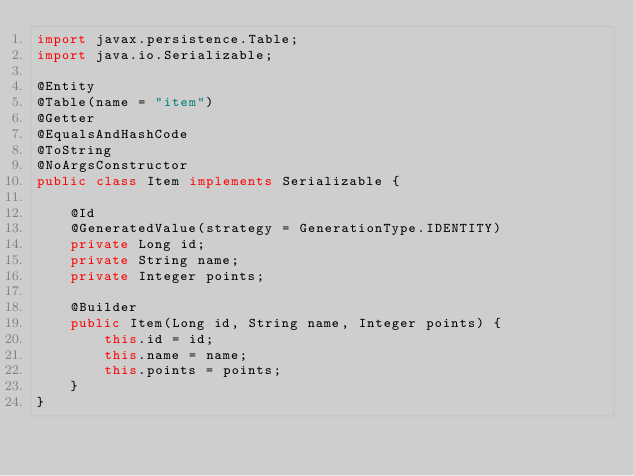<code> <loc_0><loc_0><loc_500><loc_500><_Java_>import javax.persistence.Table;
import java.io.Serializable;

@Entity
@Table(name = "item")
@Getter
@EqualsAndHashCode
@ToString
@NoArgsConstructor
public class Item implements Serializable {

    @Id
    @GeneratedValue(strategy = GenerationType.IDENTITY)
    private Long id;
    private String name;
    private Integer points;

    @Builder
    public Item(Long id, String name, Integer points) {
        this.id = id;
        this.name = name;
        this.points = points;
    }
}
</code> 